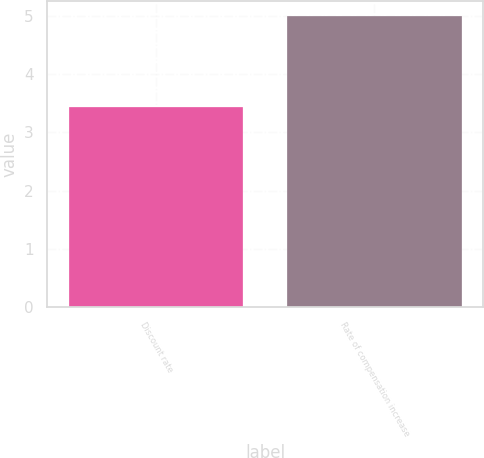<chart> <loc_0><loc_0><loc_500><loc_500><bar_chart><fcel>Discount rate<fcel>Rate of compensation increase<nl><fcel>3.44<fcel>5<nl></chart> 